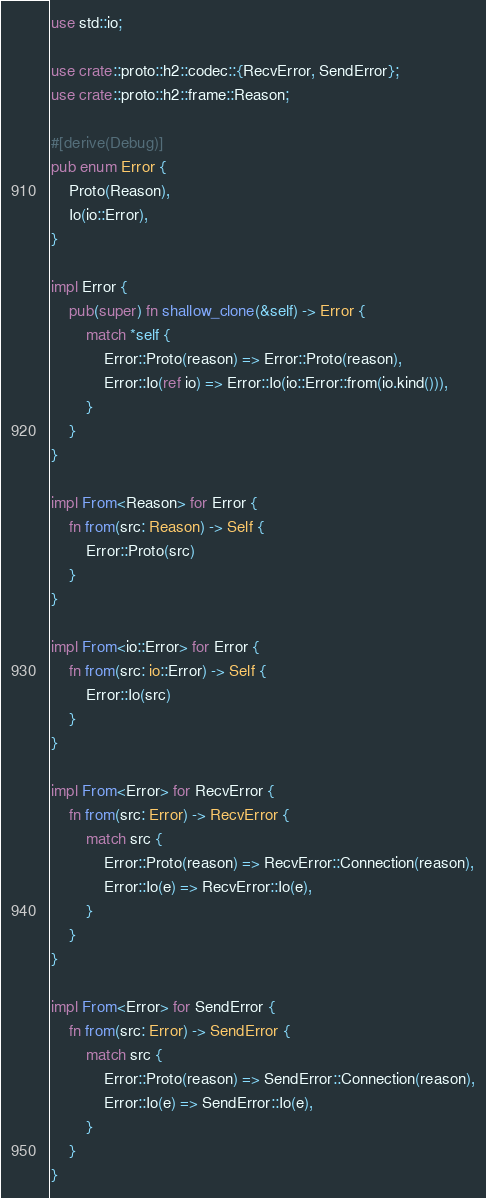<code> <loc_0><loc_0><loc_500><loc_500><_Rust_>use std::io;

use crate::proto::h2::codec::{RecvError, SendError};
use crate::proto::h2::frame::Reason;

#[derive(Debug)]
pub enum Error {
    Proto(Reason),
    Io(io::Error),
}

impl Error {
    pub(super) fn shallow_clone(&self) -> Error {
        match *self {
            Error::Proto(reason) => Error::Proto(reason),
            Error::Io(ref io) => Error::Io(io::Error::from(io.kind())),
        }
    }
}

impl From<Reason> for Error {
    fn from(src: Reason) -> Self {
        Error::Proto(src)
    }
}

impl From<io::Error> for Error {
    fn from(src: io::Error) -> Self {
        Error::Io(src)
    }
}

impl From<Error> for RecvError {
    fn from(src: Error) -> RecvError {
        match src {
            Error::Proto(reason) => RecvError::Connection(reason),
            Error::Io(e) => RecvError::Io(e),
        }
    }
}

impl From<Error> for SendError {
    fn from(src: Error) -> SendError {
        match src {
            Error::Proto(reason) => SendError::Connection(reason),
            Error::Io(e) => SendError::Io(e),
        }
    }
}
</code> 